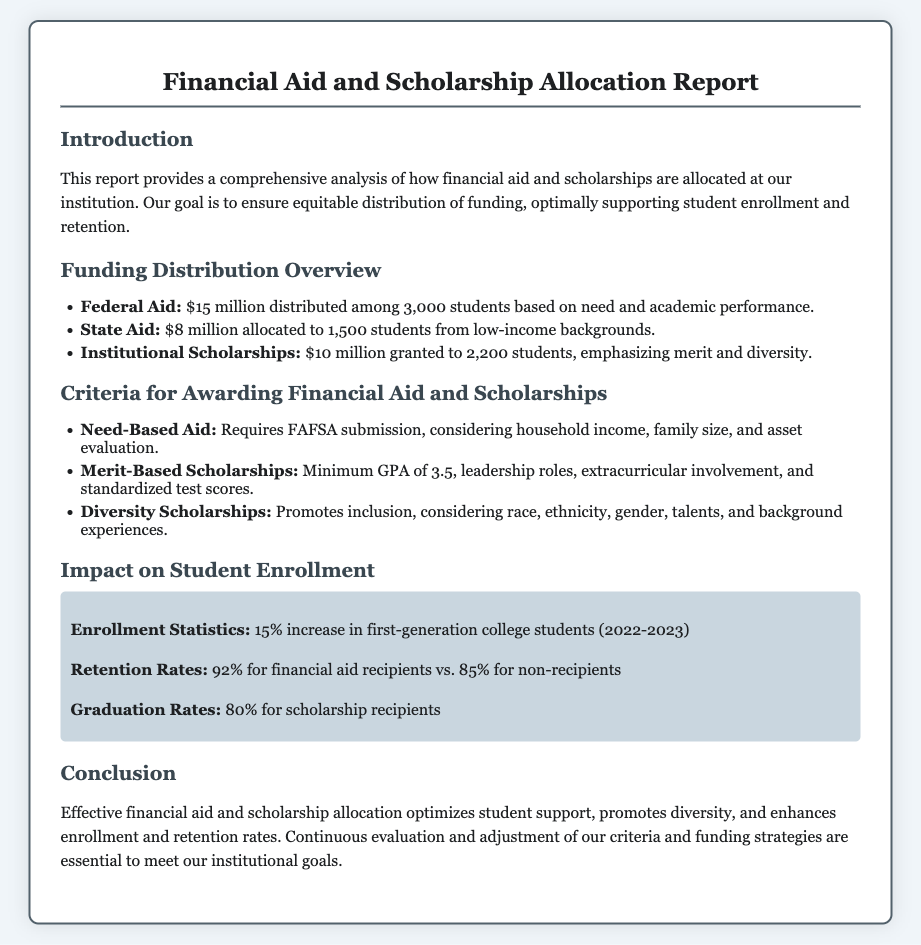what is the total amount of federal aid distributed? The total amount of federal aid distributed is stated in the funding distribution overview section, which is $15 million.
Answer: $15 million how many students received state aid? The document specifies that 1,500 students received state aid, as detailed in the funding distribution overview.
Answer: 1,500 students what is the minimum GPA required for merit-based scholarships? The criteria for awarding scholarships mention a minimum GPA, which is 3.5.
Answer: 3.5 what percentage of financial aid recipients graduated? The graduation rates for scholarship recipients are detailed in the impact on student enrollment section, which states 80%.
Answer: 80% what was the increase percentage for first-generation college students? The enrollment statistics indicate a 15% increase in first-generation college students for the 2022-2023 academic year.
Answer: 15% which type of scholarships promotes inclusion? The document mentions diversity scholarships as the type that promotes inclusion.
Answer: Diversity Scholarships what is the retention rate for financial aid recipients? The retention rates for financial aid recipients are specifically noted as 92%, allowing for easy retrieval of this information.
Answer: 92% what are the criteria considered for need-based aid? The criteria for need-based aid include FAFSA submission, household income, family size, and asset evaluation, as stated in the corresponding section.
Answer: FAFSA submission, household income, family size, asset evaluation how many students received institutional scholarships? The funding distribution overview states that 2,200 students received institutional scholarships.
Answer: 2,200 students 